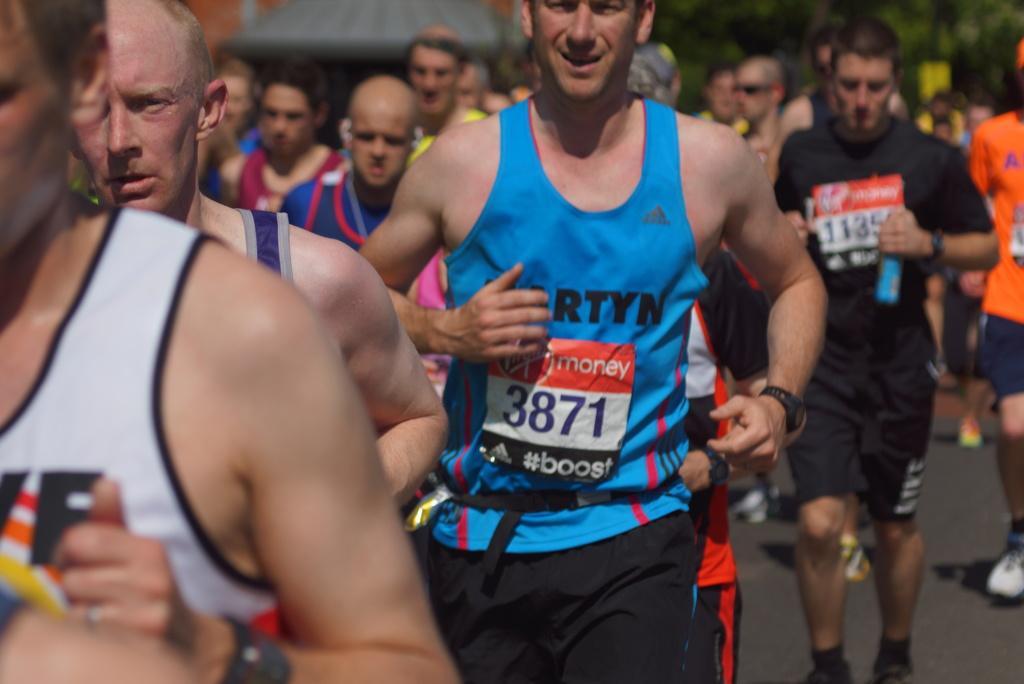How would you summarize this image in a sentence or two? In this image, we can see persons wearing clothes. 